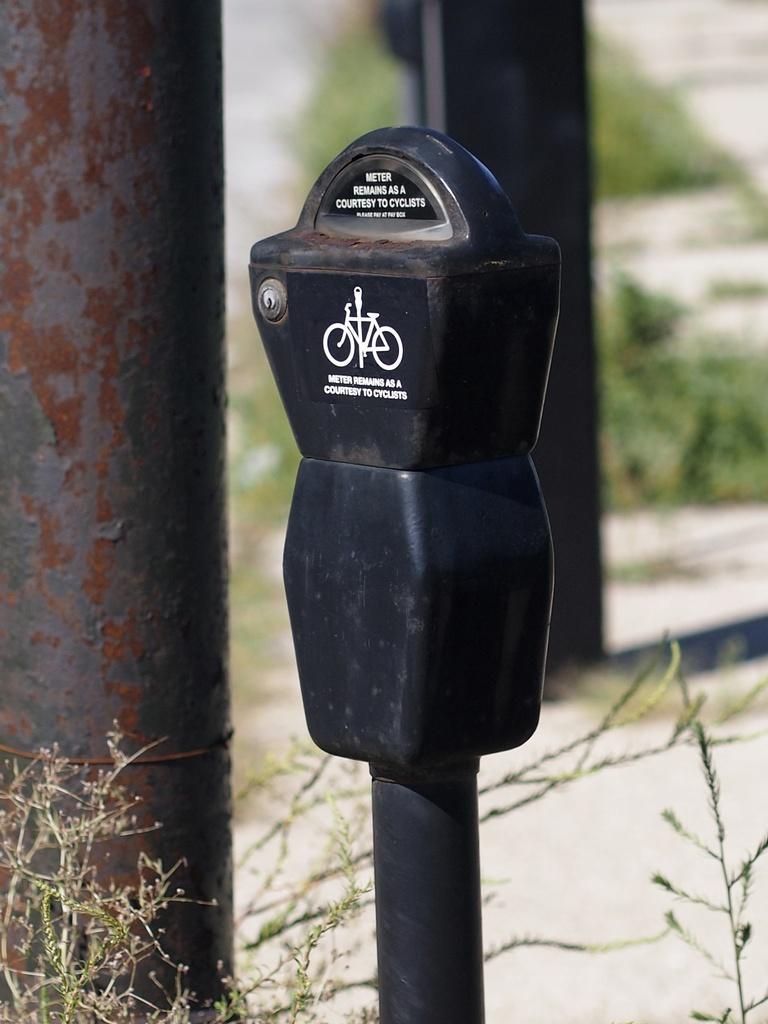Please provide a concise description of this image. In this picture we can see a pole with a black meter. Behind the black meter there is another pole and blurred background. 